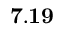Convert formula to latex. <formula><loc_0><loc_0><loc_500><loc_500>7 . 1 9</formula> 